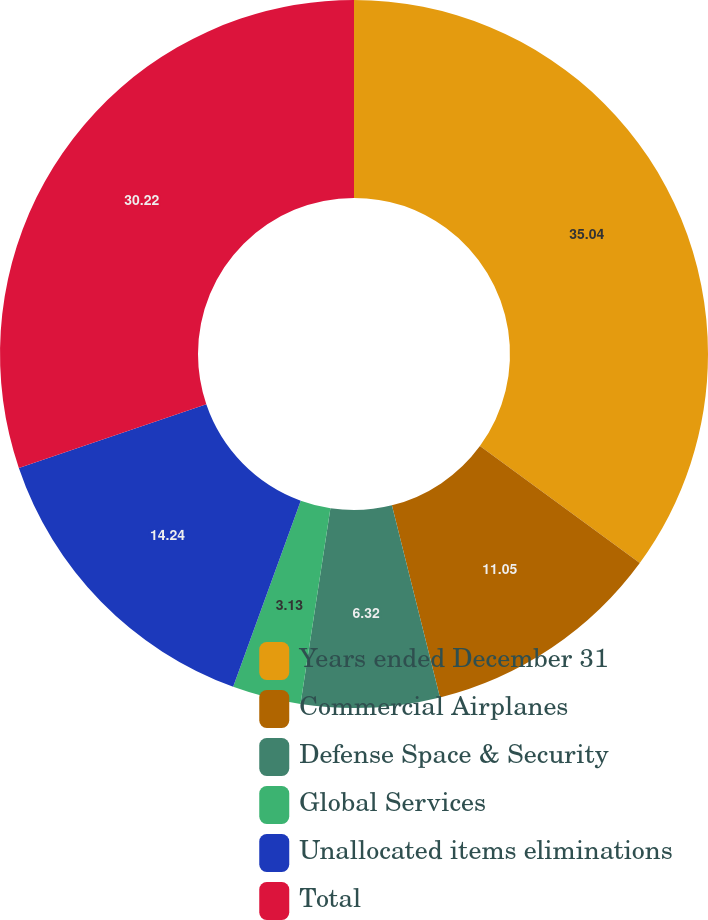Convert chart. <chart><loc_0><loc_0><loc_500><loc_500><pie_chart><fcel>Years ended December 31<fcel>Commercial Airplanes<fcel>Defense Space & Security<fcel>Global Services<fcel>Unallocated items eliminations<fcel>Total<nl><fcel>35.05%<fcel>11.05%<fcel>6.32%<fcel>3.13%<fcel>14.24%<fcel>30.22%<nl></chart> 